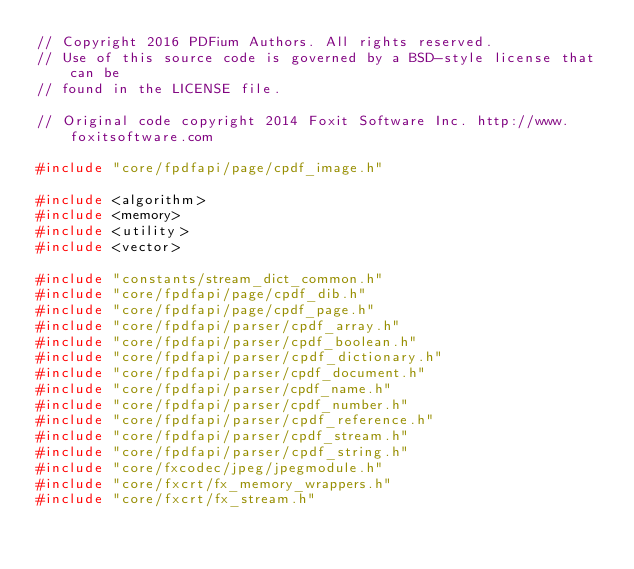<code> <loc_0><loc_0><loc_500><loc_500><_C++_>// Copyright 2016 PDFium Authors. All rights reserved.
// Use of this source code is governed by a BSD-style license that can be
// found in the LICENSE file.

// Original code copyright 2014 Foxit Software Inc. http://www.foxitsoftware.com

#include "core/fpdfapi/page/cpdf_image.h"

#include <algorithm>
#include <memory>
#include <utility>
#include <vector>

#include "constants/stream_dict_common.h"
#include "core/fpdfapi/page/cpdf_dib.h"
#include "core/fpdfapi/page/cpdf_page.h"
#include "core/fpdfapi/parser/cpdf_array.h"
#include "core/fpdfapi/parser/cpdf_boolean.h"
#include "core/fpdfapi/parser/cpdf_dictionary.h"
#include "core/fpdfapi/parser/cpdf_document.h"
#include "core/fpdfapi/parser/cpdf_name.h"
#include "core/fpdfapi/parser/cpdf_number.h"
#include "core/fpdfapi/parser/cpdf_reference.h"
#include "core/fpdfapi/parser/cpdf_stream.h"
#include "core/fpdfapi/parser/cpdf_string.h"
#include "core/fxcodec/jpeg/jpegmodule.h"
#include "core/fxcrt/fx_memory_wrappers.h"
#include "core/fxcrt/fx_stream.h"</code> 